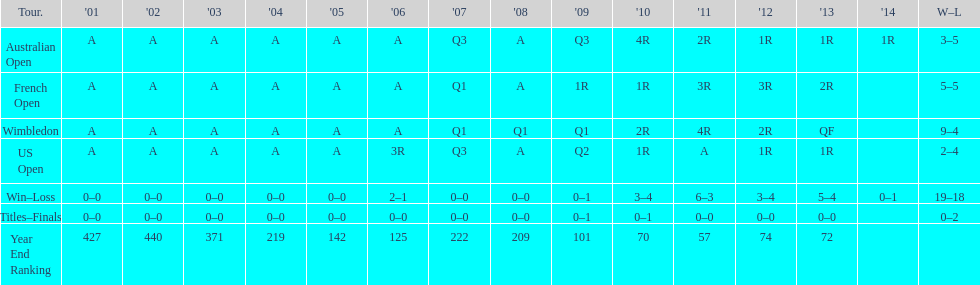What was the ranking of this player following 2005? 125. 